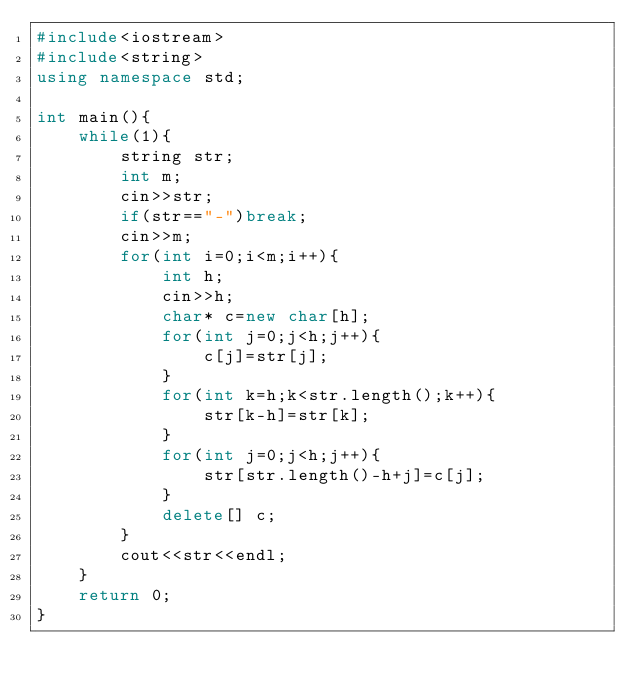<code> <loc_0><loc_0><loc_500><loc_500><_C++_>#include<iostream>
#include<string>
using namespace std;

int main(){
    while(1){
        string str;
        int m;
        cin>>str;
        if(str=="-")break;
        cin>>m;
        for(int i=0;i<m;i++){
            int h;
            cin>>h;
            char* c=new char[h];
            for(int j=0;j<h;j++){
                c[j]=str[j];
            }
            for(int k=h;k<str.length();k++){
                str[k-h]=str[k];
            }
            for(int j=0;j<h;j++){
                str[str.length()-h+j]=c[j];
            }
            delete[] c;
        }
        cout<<str<<endl;
    }
    return 0;
}
</code> 